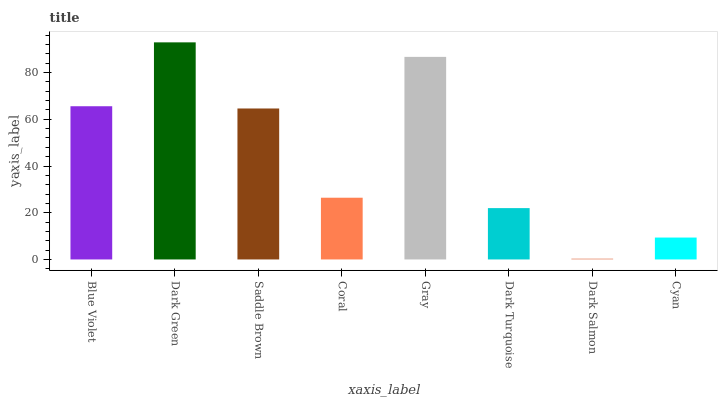Is Dark Salmon the minimum?
Answer yes or no. Yes. Is Dark Green the maximum?
Answer yes or no. Yes. Is Saddle Brown the minimum?
Answer yes or no. No. Is Saddle Brown the maximum?
Answer yes or no. No. Is Dark Green greater than Saddle Brown?
Answer yes or no. Yes. Is Saddle Brown less than Dark Green?
Answer yes or no. Yes. Is Saddle Brown greater than Dark Green?
Answer yes or no. No. Is Dark Green less than Saddle Brown?
Answer yes or no. No. Is Saddle Brown the high median?
Answer yes or no. Yes. Is Coral the low median?
Answer yes or no. Yes. Is Gray the high median?
Answer yes or no. No. Is Dark Green the low median?
Answer yes or no. No. 